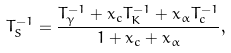Convert formula to latex. <formula><loc_0><loc_0><loc_500><loc_500>T _ { S } ^ { - 1 } = \frac { T _ { \gamma } ^ { - 1 } + x _ { c } T _ { K } ^ { - 1 } + x _ { \alpha } T _ { c } ^ { - 1 } } { 1 + x _ { c } + x _ { \alpha } } ,</formula> 